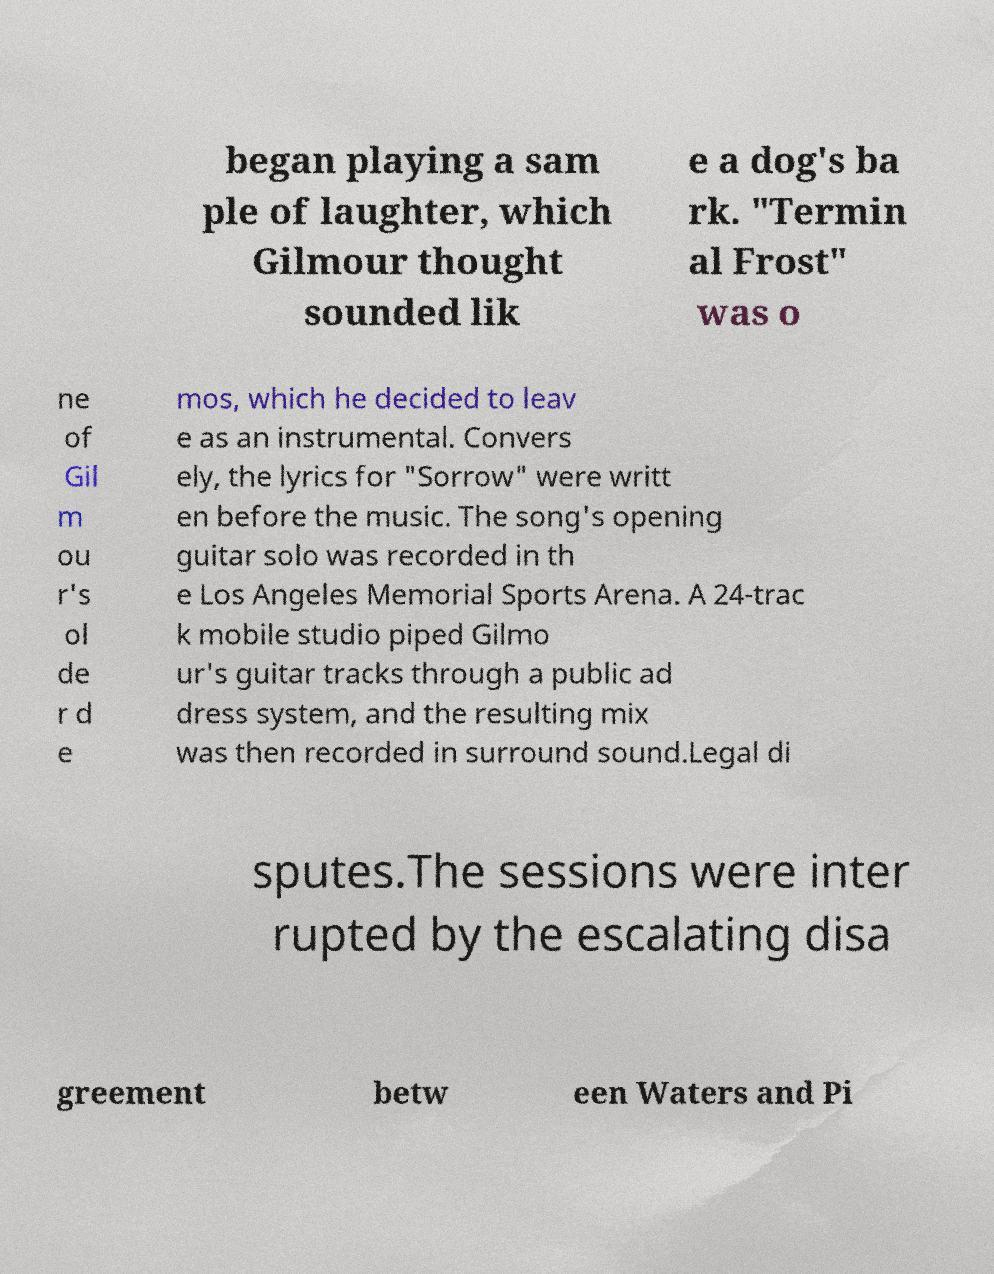Please read and relay the text visible in this image. What does it say? began playing a sam ple of laughter, which Gilmour thought sounded lik e a dog's ba rk. "Termin al Frost" was o ne of Gil m ou r's ol de r d e mos, which he decided to leav e as an instrumental. Convers ely, the lyrics for "Sorrow" were writt en before the music. The song's opening guitar solo was recorded in th e Los Angeles Memorial Sports Arena. A 24-trac k mobile studio piped Gilmo ur's guitar tracks through a public ad dress system, and the resulting mix was then recorded in surround sound.Legal di sputes.The sessions were inter rupted by the escalating disa greement betw een Waters and Pi 